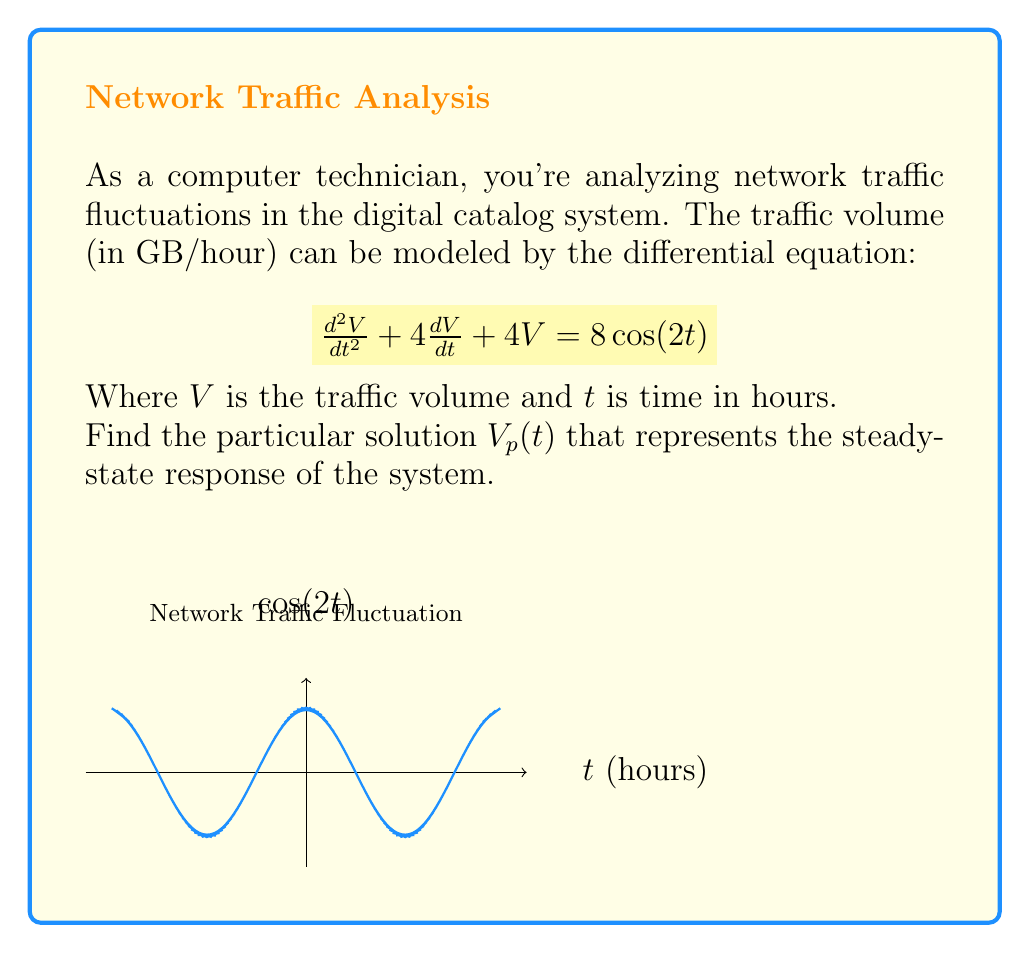Give your solution to this math problem. To find the particular solution $V_p(t)$, we follow these steps:

1) The forcing function is $8\cos(2t)$, so we assume a particular solution of the form:
   $$V_p(t) = A\cos(2t) + B\sin(2t)$$

2) We need to find $V_p'(t)$ and $V_p''(t)$:
   $$V_p'(t) = -2A\sin(2t) + 2B\cos(2t)$$
   $$V_p''(t) = -4A\cos(2t) - 4B\sin(2t)$$

3) Substitute these into the original equation:
   $$(-4A\cos(2t) - 4B\sin(2t)) + 4(-2A\sin(2t) + 2B\cos(2t)) + 4(A\cos(2t) + B\sin(2t)) = 8\cos(2t)$$

4) Simplify:
   $$(-4A + 8B + 4A)\cos(2t) + (-4B - 8A + 4B)\sin(2t) = 8\cos(2t)$$
   $$(8B)\cos(2t) + (-8A)\sin(2t) = 8\cos(2t)$$

5) Equate coefficients:
   $$8B = 8$$
   $$-8A = 0$$

6) Solve for A and B:
   $$B = 1$$
   $$A = 0$$

7) Therefore, the particular solution is:
   $$V_p(t) = \sin(2t)$$
Answer: $V_p(t) = \sin(2t)$ 